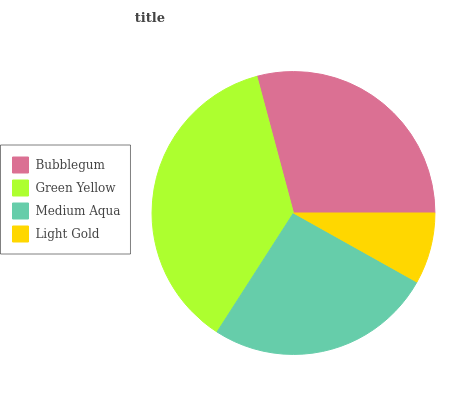Is Light Gold the minimum?
Answer yes or no. Yes. Is Green Yellow the maximum?
Answer yes or no. Yes. Is Medium Aqua the minimum?
Answer yes or no. No. Is Medium Aqua the maximum?
Answer yes or no. No. Is Green Yellow greater than Medium Aqua?
Answer yes or no. Yes. Is Medium Aqua less than Green Yellow?
Answer yes or no. Yes. Is Medium Aqua greater than Green Yellow?
Answer yes or no. No. Is Green Yellow less than Medium Aqua?
Answer yes or no. No. Is Bubblegum the high median?
Answer yes or no. Yes. Is Medium Aqua the low median?
Answer yes or no. Yes. Is Medium Aqua the high median?
Answer yes or no. No. Is Light Gold the low median?
Answer yes or no. No. 